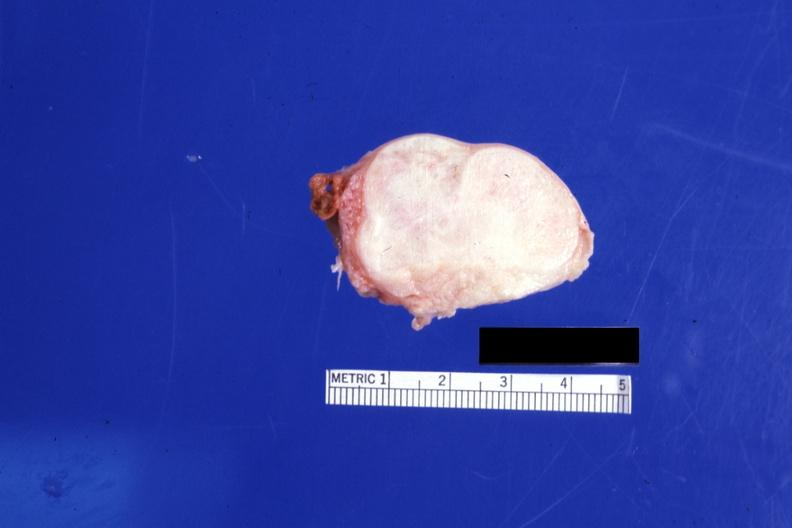s female reproductive present?
Answer the question using a single word or phrase. Yes 